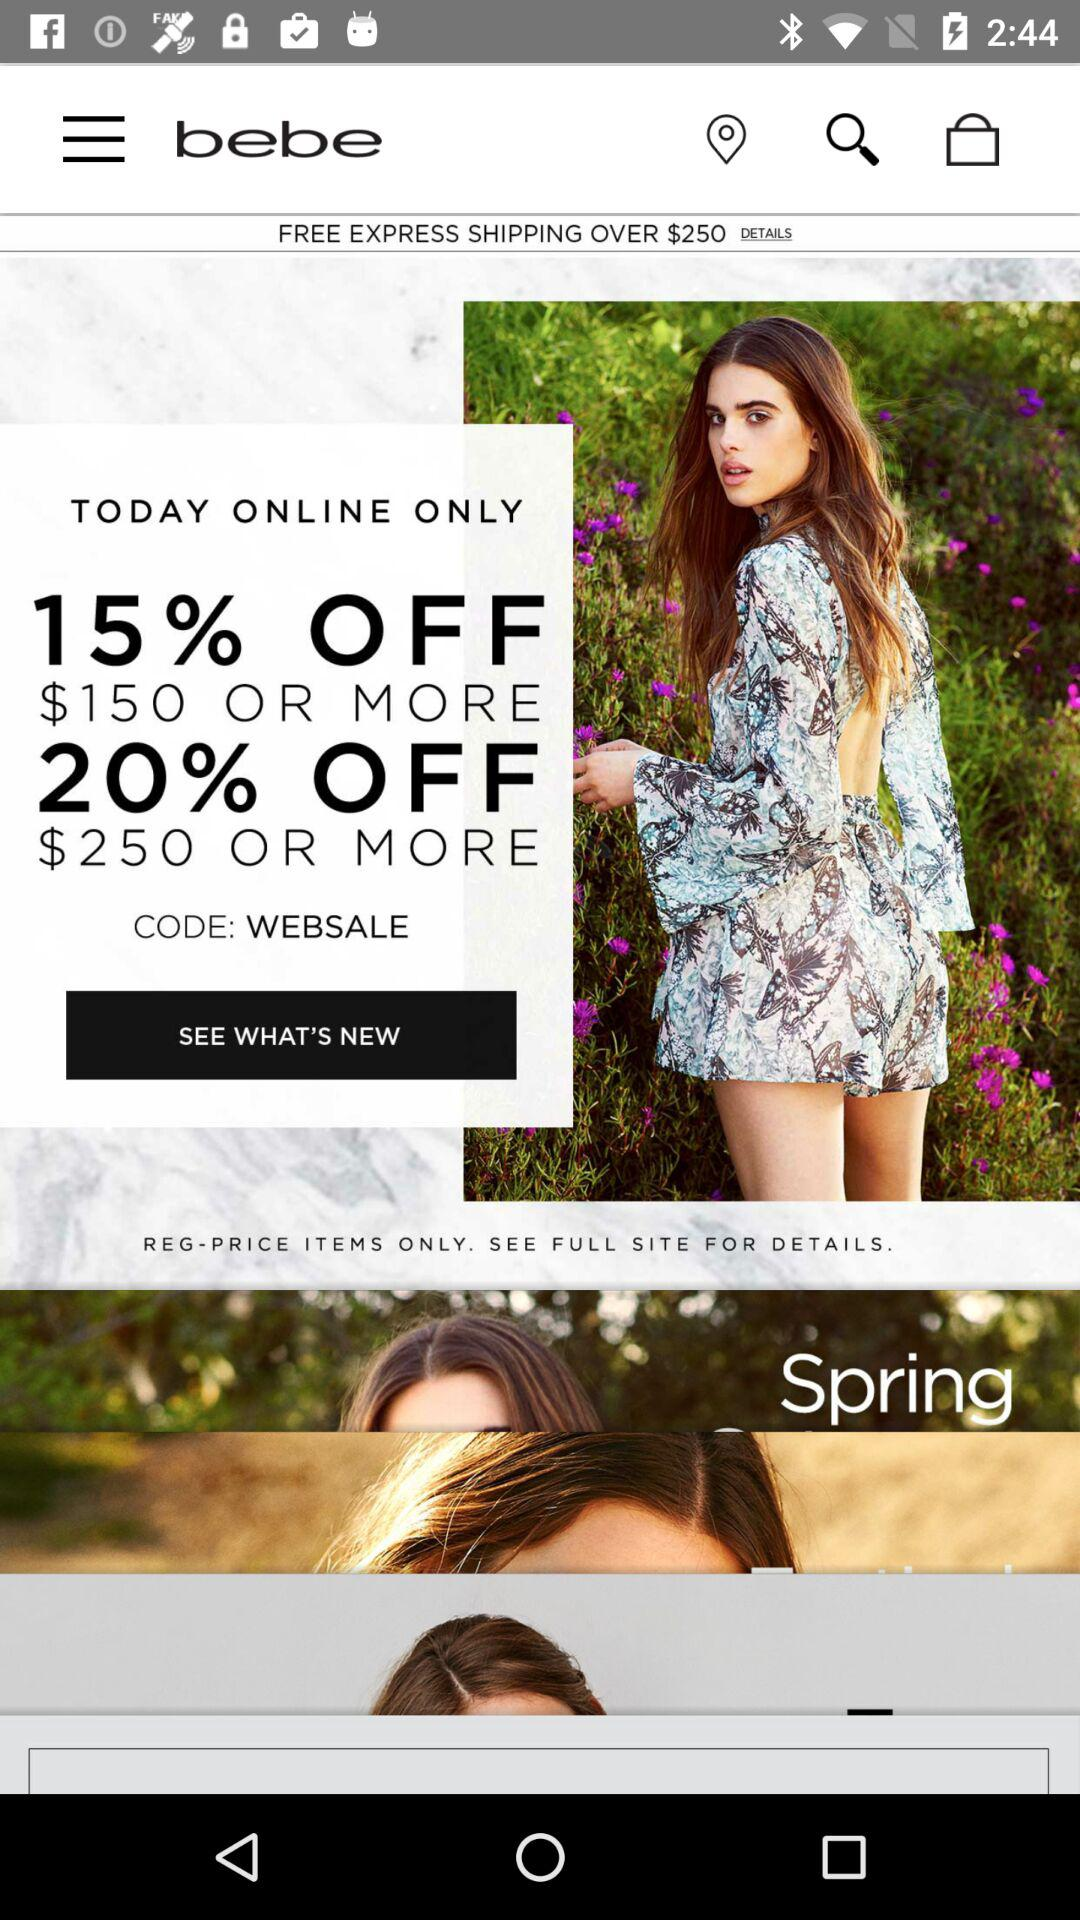What is the application name? The application name is "bebe". 